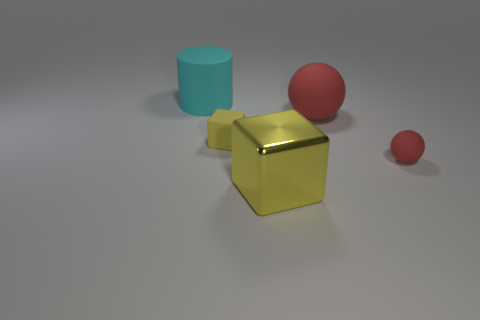Add 2 big gray metallic cylinders. How many objects exist? 7 Subtract all cylinders. How many objects are left? 4 Subtract all large gray metal things. Subtract all matte things. How many objects are left? 1 Add 3 yellow rubber things. How many yellow rubber things are left? 4 Add 3 large cyan objects. How many large cyan objects exist? 4 Subtract 0 green blocks. How many objects are left? 5 